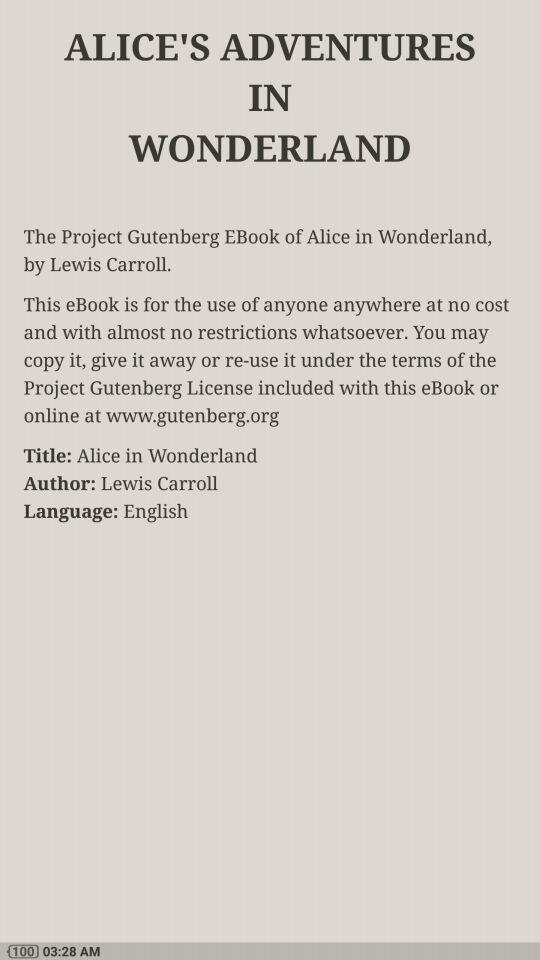What is the name of the author? The name of the author is Lewis Carroll. 